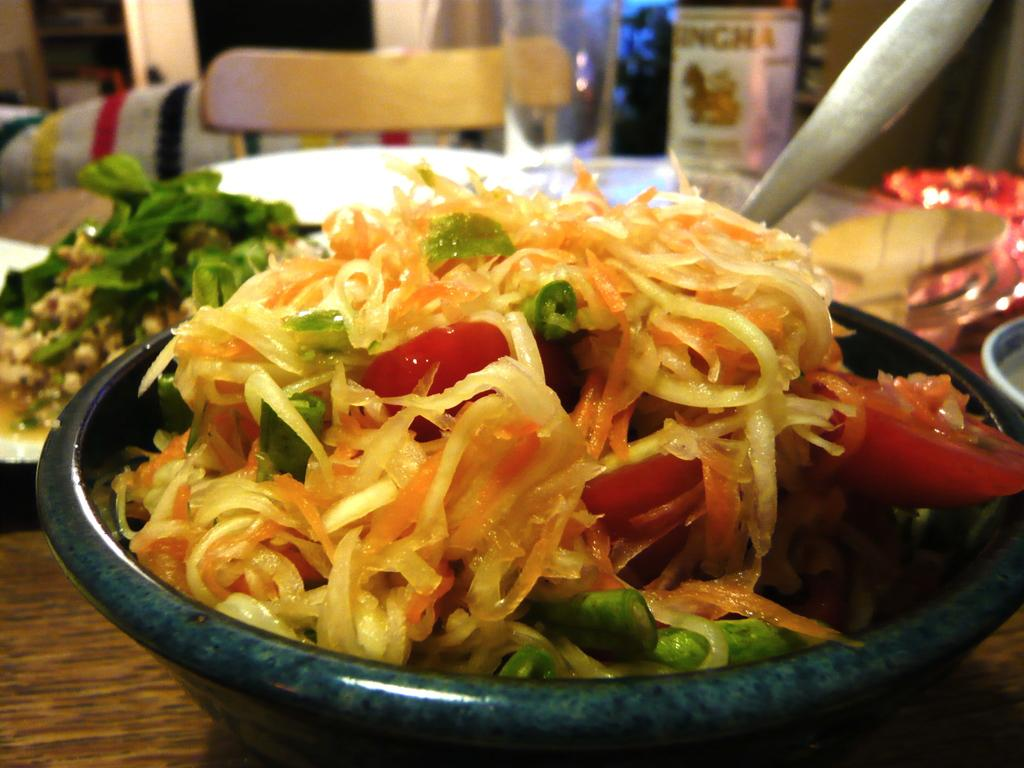What is the main object in the center of the image? There is a table in the center of the image. What items can be seen on the table? Bowls, plates, spoons, and a spatula are on the table. What else is present on the table? Food is placed on the table. What can be seen in the background of the image? There is a chair and a wall in the background of the image. How many seeds are visible on the table in the image? There is no mention of seeds in the image; the focus is on bowls, plates, spoons, a spatula, and food. What type of account is being discussed in the image? There is no mention of an account in the image; the focus is on a table, its contents, and the background. 